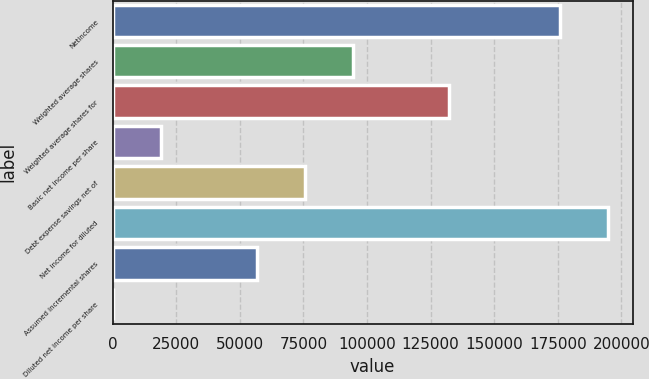Convert chart. <chart><loc_0><loc_0><loc_500><loc_500><bar_chart><fcel>Netincome<fcel>Weighted average shares<fcel>Weighted average shares for<fcel>Basic net income per share<fcel>Debt expense savings net of<fcel>Net income for diluted<fcel>Assumed incremental shares<fcel>Diluted net income per share<nl><fcel>175791<fcel>94402.2<fcel>132162<fcel>18882.4<fcel>75522.3<fcel>194671<fcel>56642.3<fcel>2.49<nl></chart> 